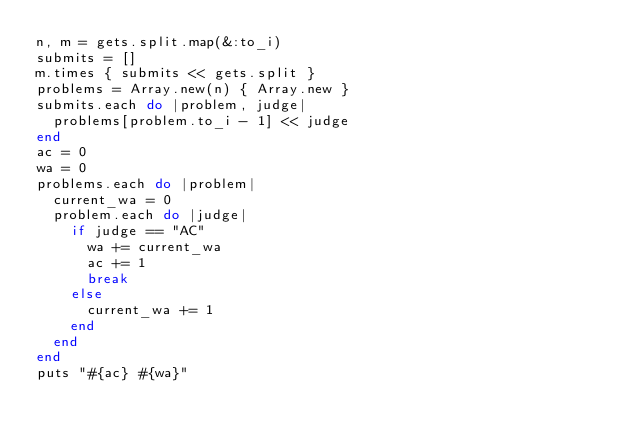<code> <loc_0><loc_0><loc_500><loc_500><_Ruby_>n, m = gets.split.map(&:to_i)
submits = []
m.times { submits << gets.split }
problems = Array.new(n) { Array.new }
submits.each do |problem, judge|
  problems[problem.to_i - 1] << judge
end
ac = 0
wa = 0
problems.each do |problem|
  current_wa = 0
  problem.each do |judge|
    if judge == "AC"
      wa += current_wa
      ac += 1
      break
    else
      current_wa += 1
    end
  end
end
puts "#{ac} #{wa}"
</code> 